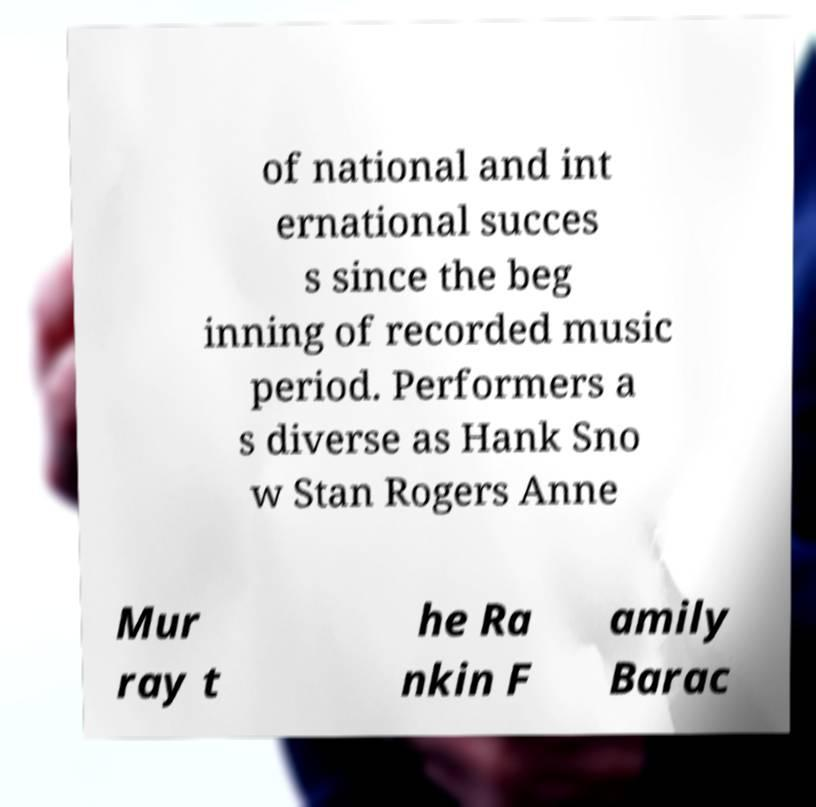Could you extract and type out the text from this image? of national and int ernational succes s since the beg inning of recorded music period. Performers a s diverse as Hank Sno w Stan Rogers Anne Mur ray t he Ra nkin F amily Barac 